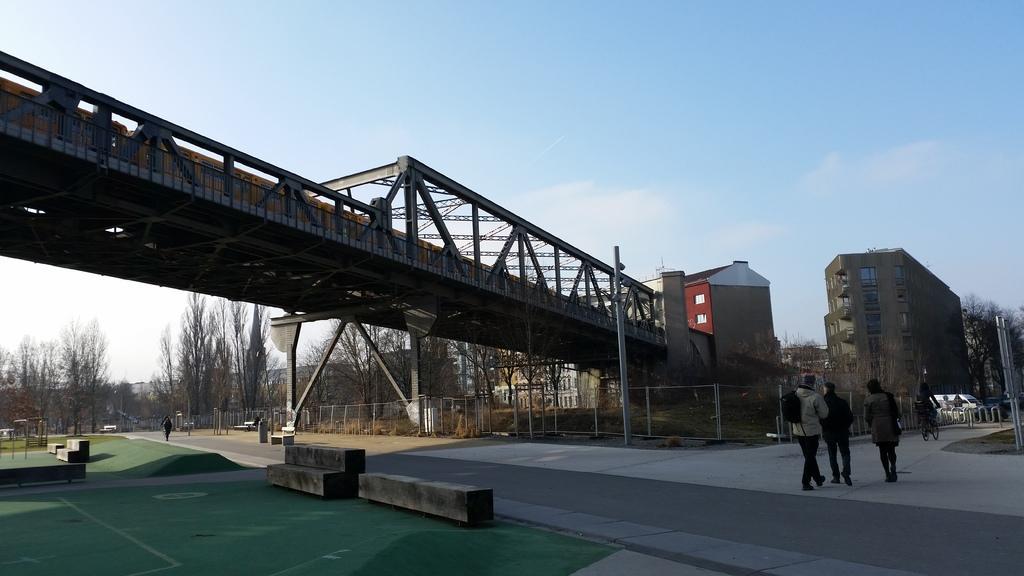Describe this image in one or two sentences. At the bottom of the picture, we see the road and the cement blocks. On the right side, we see three people are walking on the road. In front of them, we see a man riding a bicycle. On the right side, we see a pole and the trees. In the middle, we see a bridge and a pole. Behind the pole, we see the fence. On the left side, we see the trees and the cement blocks. Beside that, we see a man is walking on the road. There are trees, buildings and the poles in the background. At the top, we see the clouds and the sky. 